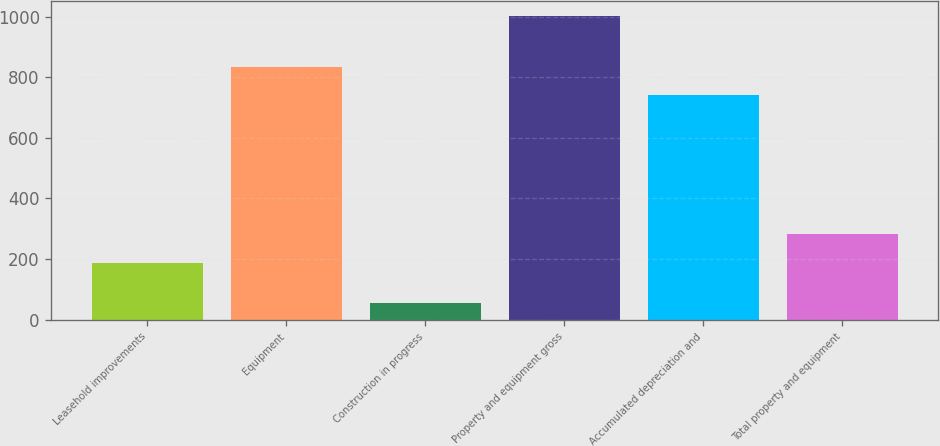Convert chart to OTSL. <chart><loc_0><loc_0><loc_500><loc_500><bar_chart><fcel>Leasehold improvements<fcel>Equipment<fcel>Construction in progress<fcel>Property and equipment gross<fcel>Accumulated depreciation and<fcel>Total property and equipment<nl><fcel>187<fcel>834.5<fcel>56<fcel>1001<fcel>740<fcel>281.5<nl></chart> 